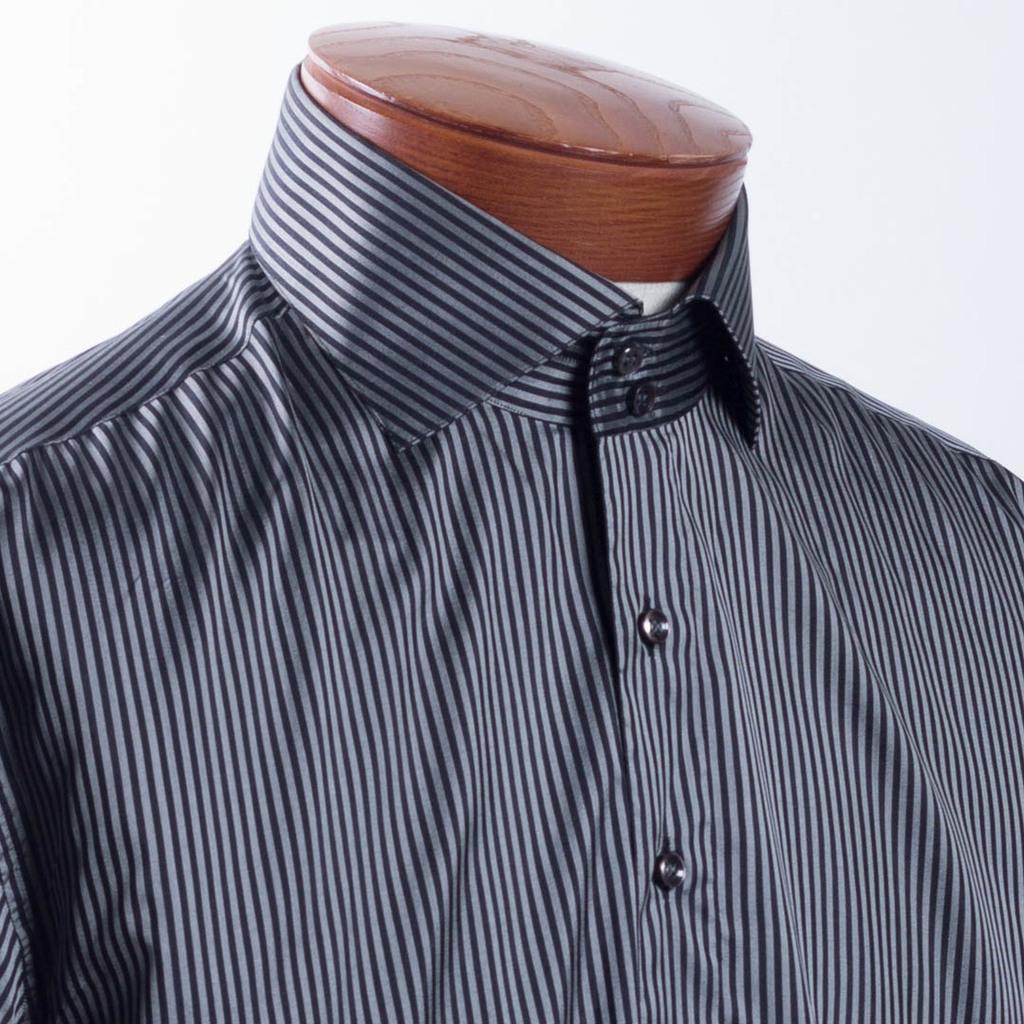Can you describe this image briefly? In this image there is a mannequin without head wearing a shirt. 